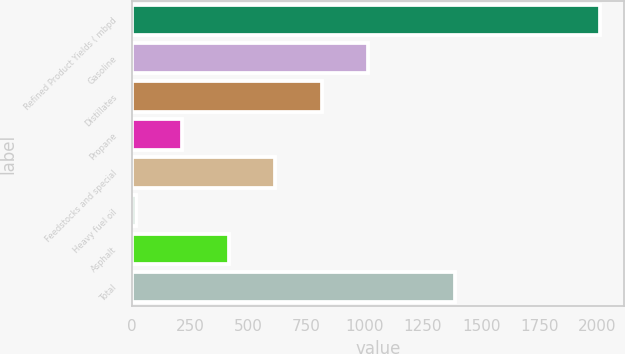<chart> <loc_0><loc_0><loc_500><loc_500><bar_chart><fcel>Refined Product Yields ( mbpd<fcel>Gasoline<fcel>Distillates<fcel>Propane<fcel>Feedstocks and special<fcel>Heavy fuel oil<fcel>Asphalt<fcel>Total<nl><fcel>2012<fcel>1015<fcel>815.6<fcel>217.4<fcel>616.2<fcel>18<fcel>416.8<fcel>1386<nl></chart> 